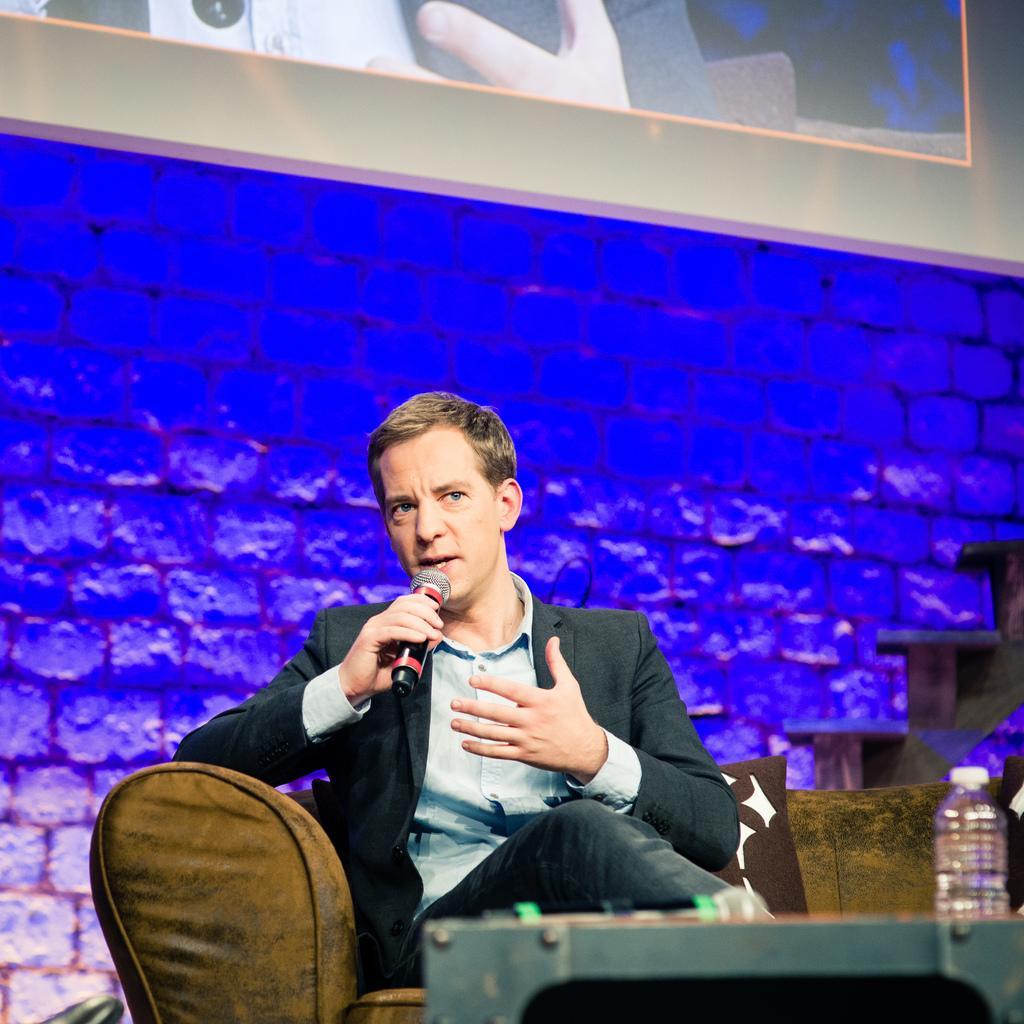Please provide a concise description of this image. In this picture we can see a man, he is sitting on a sofa and he is holding a mic, here we can see a pillow, bottle, table and in the background we can see a screen on the wall. 